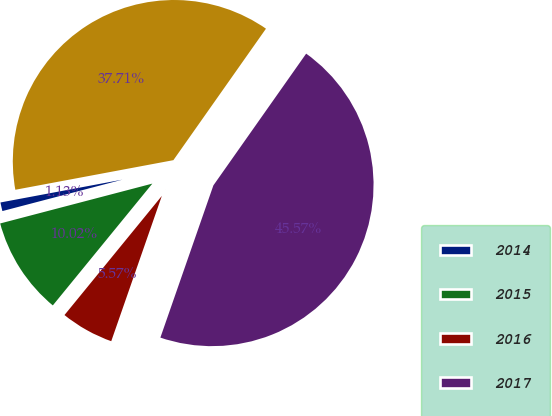Convert chart. <chart><loc_0><loc_0><loc_500><loc_500><pie_chart><fcel>2014<fcel>2015<fcel>2016<fcel>2017<fcel>2018<nl><fcel>1.13%<fcel>10.02%<fcel>5.57%<fcel>45.57%<fcel>37.71%<nl></chart> 